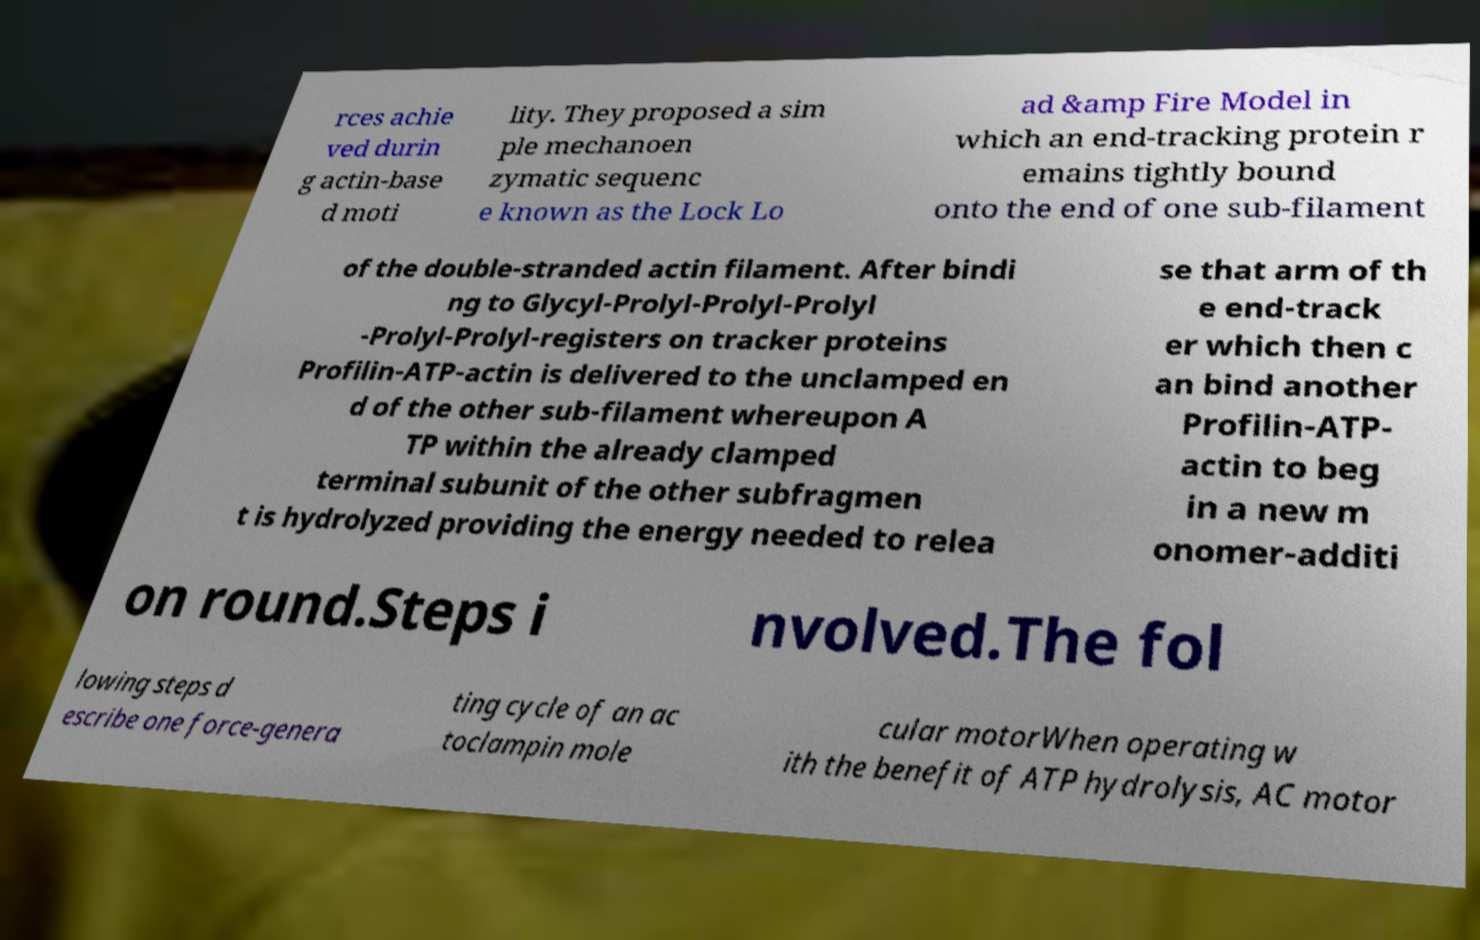Could you assist in decoding the text presented in this image and type it out clearly? rces achie ved durin g actin-base d moti lity. They proposed a sim ple mechanoen zymatic sequenc e known as the Lock Lo ad &amp Fire Model in which an end-tracking protein r emains tightly bound onto the end of one sub-filament of the double-stranded actin filament. After bindi ng to Glycyl-Prolyl-Prolyl-Prolyl -Prolyl-Prolyl-registers on tracker proteins Profilin-ATP-actin is delivered to the unclamped en d of the other sub-filament whereupon A TP within the already clamped terminal subunit of the other subfragmen t is hydrolyzed providing the energy needed to relea se that arm of th e end-track er which then c an bind another Profilin-ATP- actin to beg in a new m onomer-additi on round.Steps i nvolved.The fol lowing steps d escribe one force-genera ting cycle of an ac toclampin mole cular motorWhen operating w ith the benefit of ATP hydrolysis, AC motor 